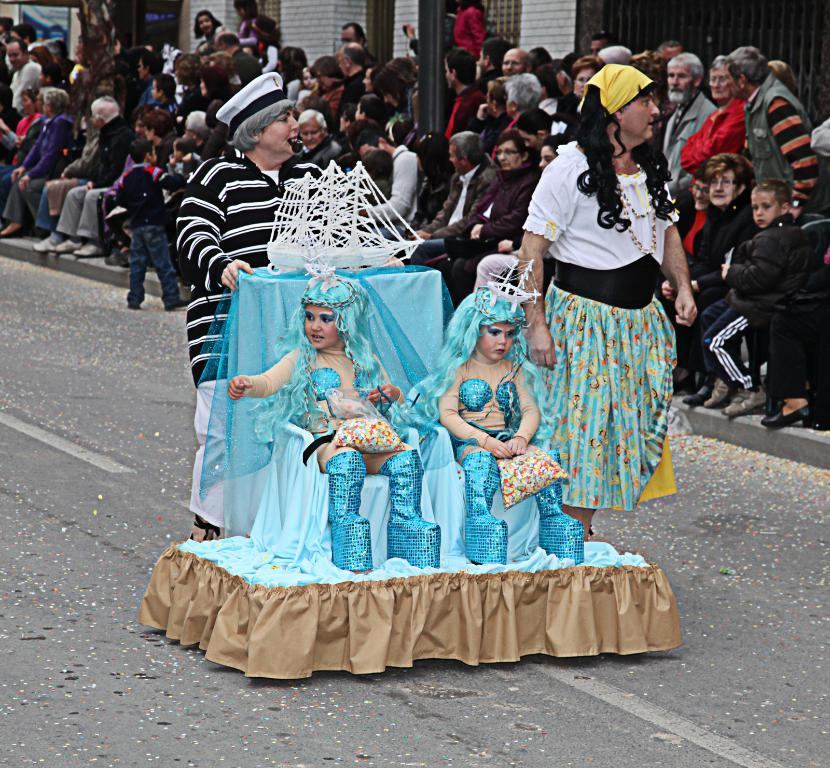How many children are sitting in the middle of the image? There are two children sitting in the middle of the image. What are the people behind the children doing? The people behind the children are standing and sitting. What can be seen at the top of the image? Poles and buildings are visible at the top of the image. What type of music can be heard coming from the kitten in the image? There is no kitten present in the image, and therefore no music can be heard coming from it. 